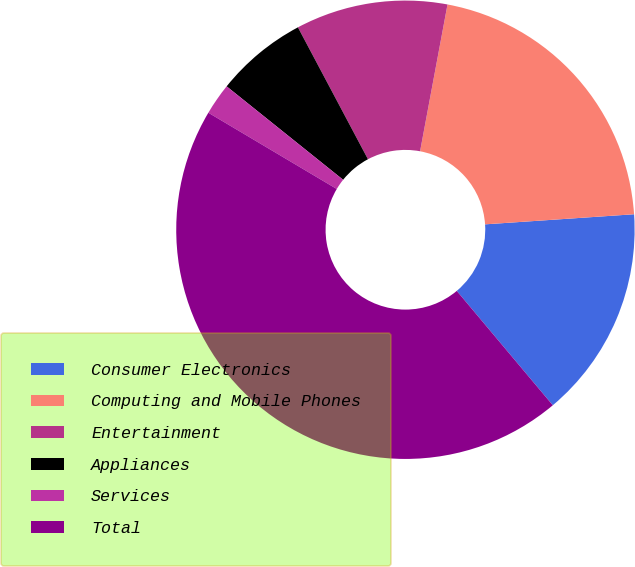<chart> <loc_0><loc_0><loc_500><loc_500><pie_chart><fcel>Consumer Electronics<fcel>Computing and Mobile Phones<fcel>Entertainment<fcel>Appliances<fcel>Services<fcel>Total<nl><fcel>14.96%<fcel>20.98%<fcel>10.71%<fcel>6.47%<fcel>2.23%<fcel>44.64%<nl></chart> 